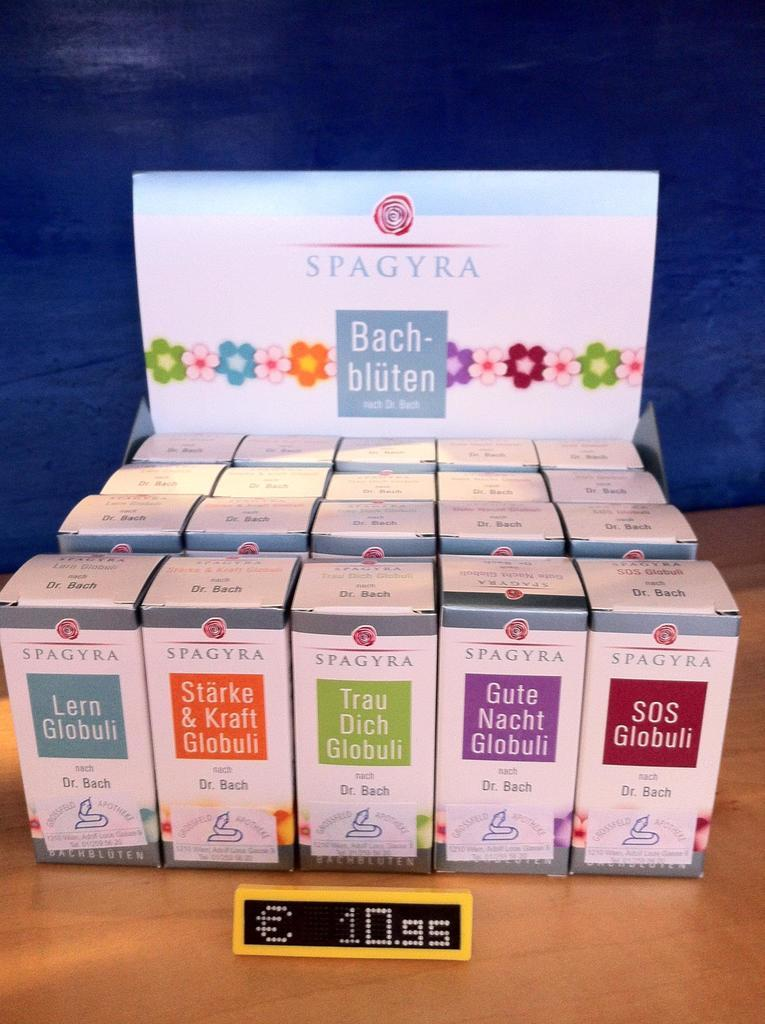<image>
Present a compact description of the photo's key features. Assorted Spagyra Bach-bluten products are on display and cost 10.95 each. 